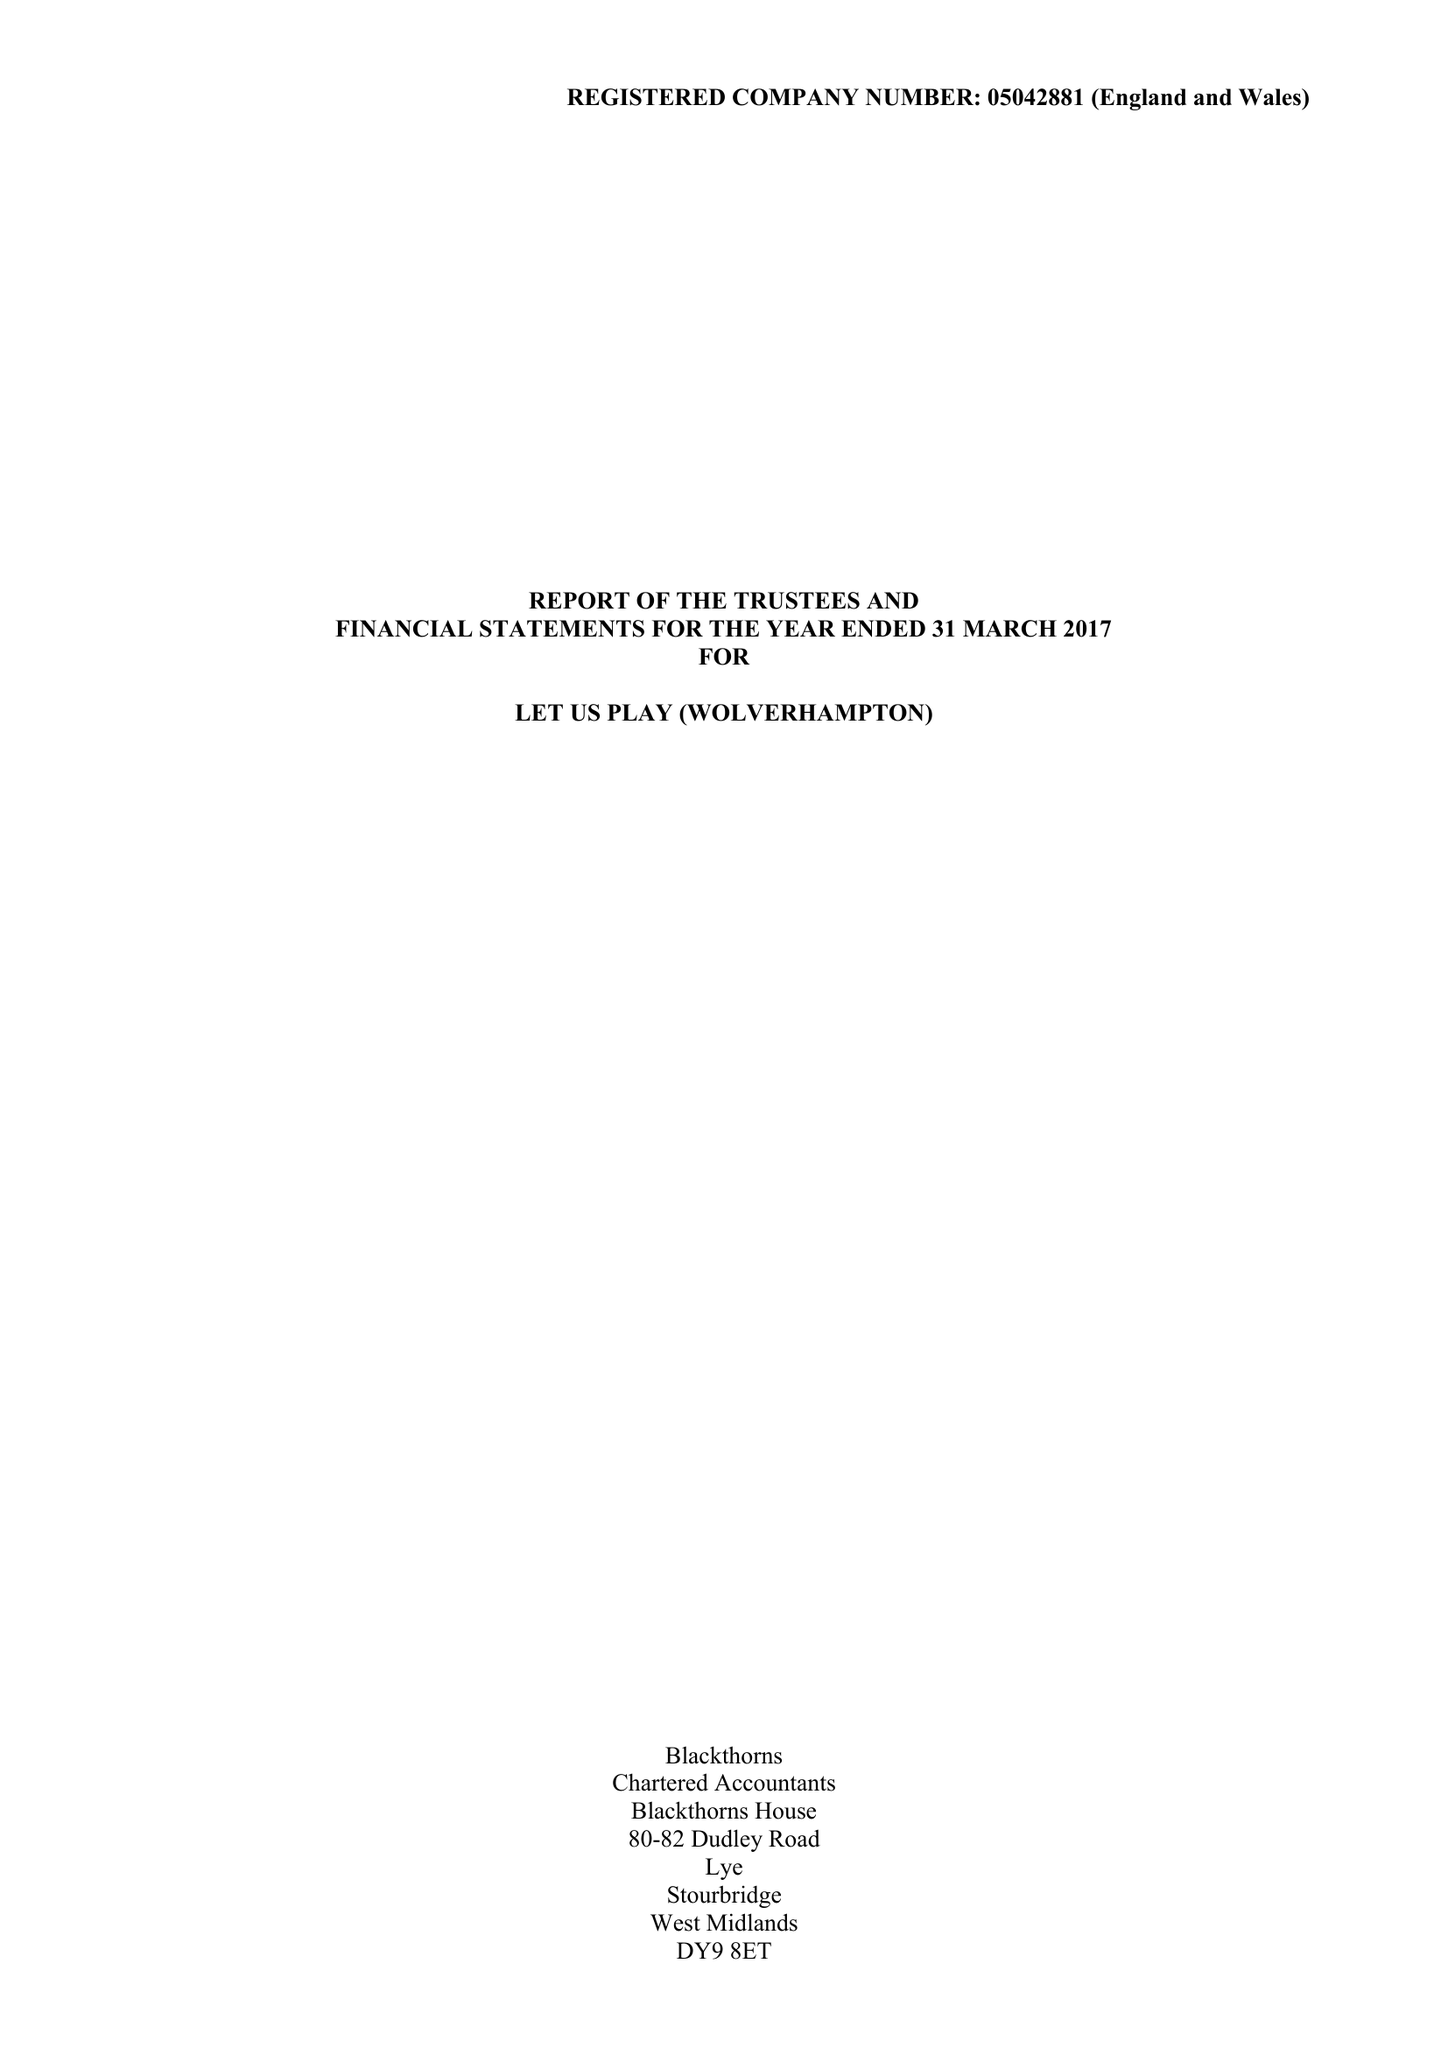What is the value for the report_date?
Answer the question using a single word or phrase. 2017-03-31 